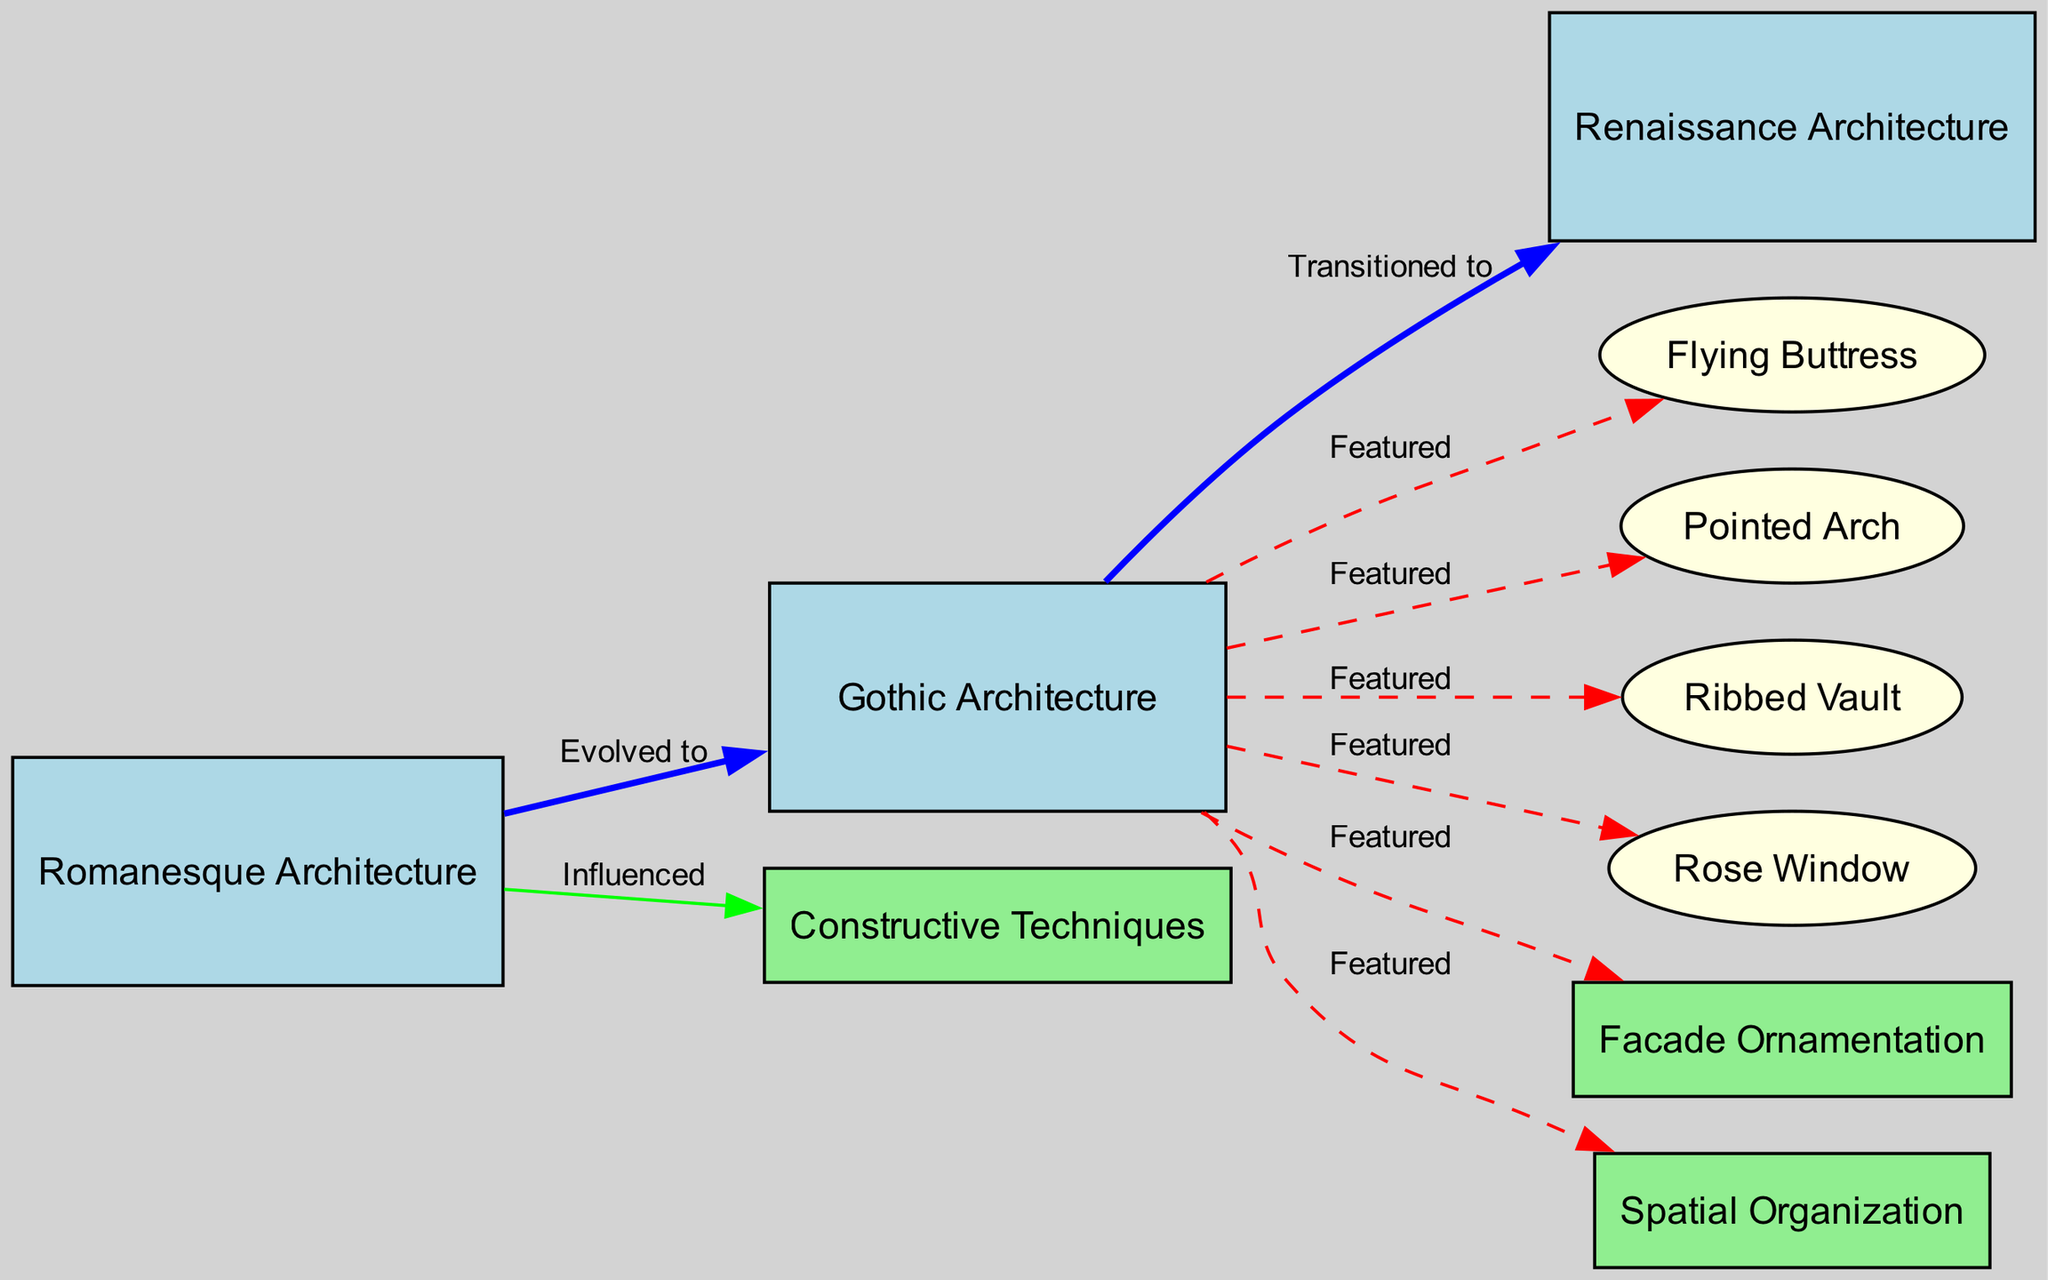What are the three types of architecture represented in the diagram? The diagram indicates three architectural styles: Romanesque Architecture, Gothic Architecture, and Renaissance Architecture. I identified these by looking for nodes labeled with "Architecture."
Answer: Romanesque Architecture, Gothic Architecture, Renaissance Architecture How many nodes are there in the diagram? By counting each unique node mentioned in the diagram's structure, I determined there are ten nodes overall.
Answer: 10 Which architectural style evolved into Gothic Architecture? By analyzing the edges in the diagram, Gothic Architecture is shown to have evolved from Romanesque Architecture, as indicated by the directed edge connecting them with the label "Evolved to."
Answer: Romanesque Architecture What feature is common to all nodes derived from Gothic Architecture? Observing the edges stemming from Gothic Architecture, each feature—Flying Buttress, Pointed Arch, Ribbed Vault, Rose Window, Facade Ornamentation, and Spatial Organization—represents a specific aspect of Gothic style, which they all share.
Answer: All are Gothic features How many features are explicitly listed under Gothic Architecture? I counted the edges connecting to Gothic Architecture, finding six features highlighted as direct characteristics or features of this style.
Answer: 6 Which style transitioned to Renaissance Architecture? The directed edge labeled "Transitioned to" explicitly depicts that Gothic Architecture evolved into Renaissance Architecture. Reviewing the diagram’s labels led me to this conclusion.
Answer: Gothic Architecture What type of influence is depicted from Romanesque Architecture to Constructive Techniques? The edge shows an "Influenced" relationship between Romanesque Architecture and Constructive Techniques, accompanied by a green line, indicating that Romanesque architecture styles informed the development of Constructive Techniques.
Answer: Influenced What color are the nodes representing architectural styles? The diagram shows that nodes related to architectural styles, specifically Romanesque, Gothic, and Renaissance Architecture, are filled in light blue. I checked the node attributes outlined in the code.
Answer: Light blue How many edges connect Gothic Architecture with its features? By counting the edges leading from Gothic Architecture, I found there are seven distinct connections representing various featured elements, which visualize the characteristics of Gothic design.
Answer: 7 